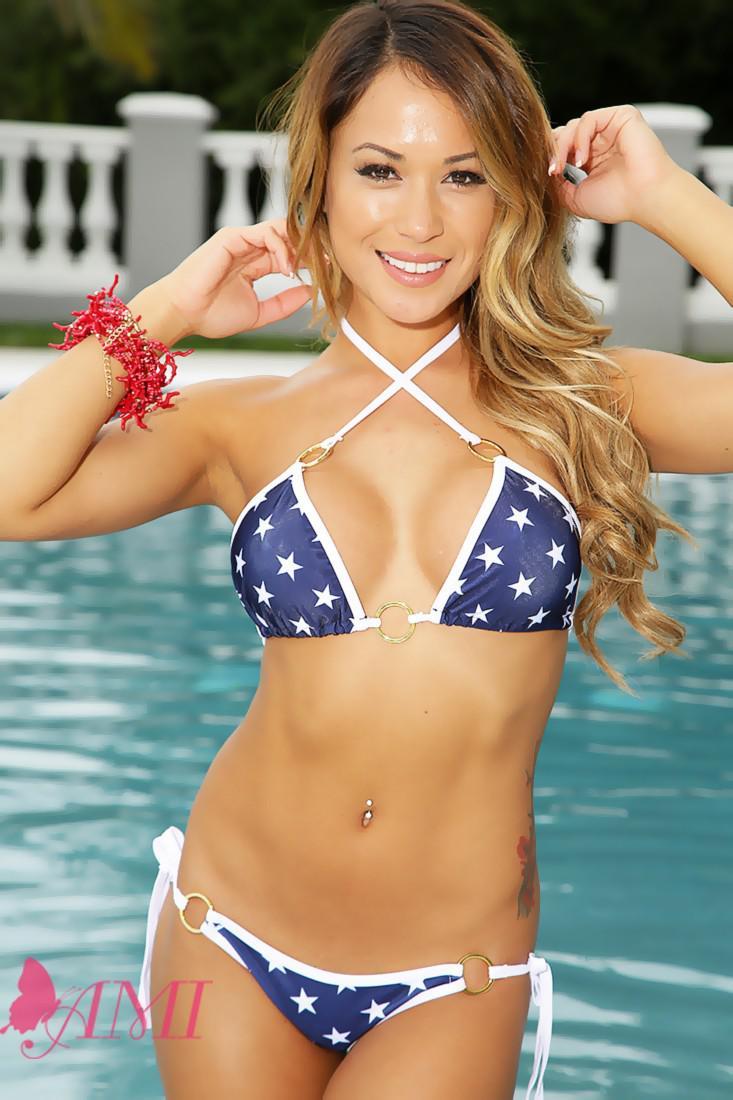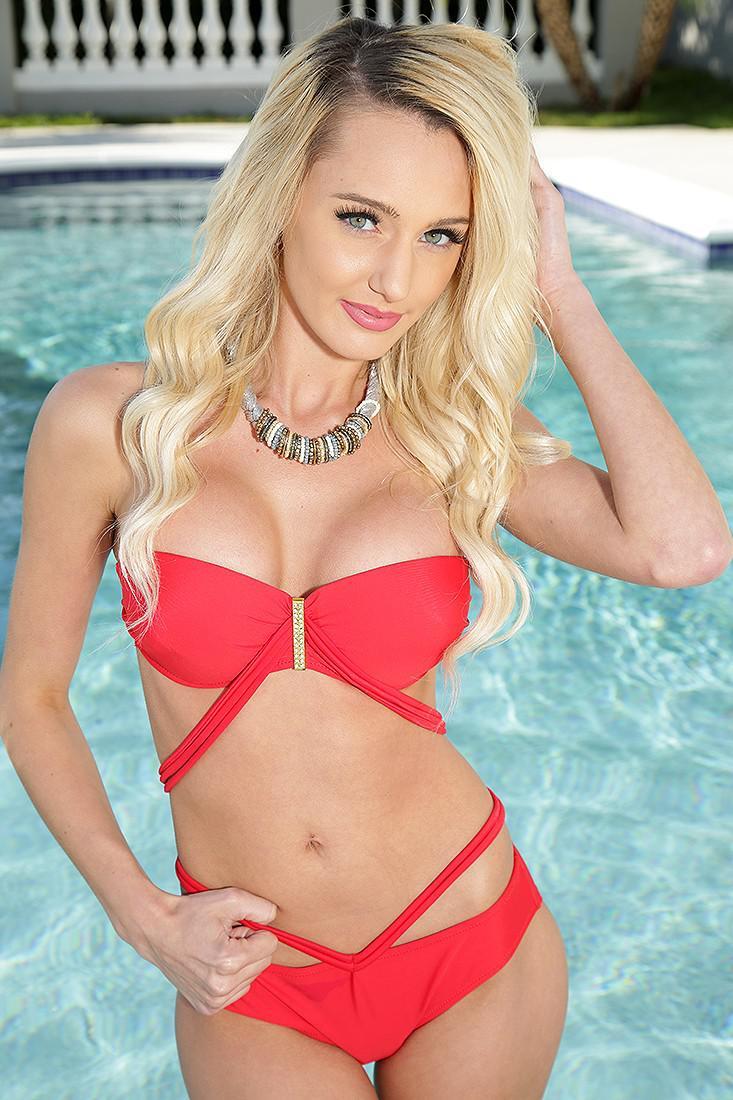The first image is the image on the left, the second image is the image on the right. Assess this claim about the two images: "In 1 of the images, 1 girl is holding her hands above her head.". Correct or not? Answer yes or no. No. The first image is the image on the left, the second image is the image on the right. Evaluate the accuracy of this statement regarding the images: "An image shows a girl in a nearly all-white bikini in front of a pool.". Is it true? Answer yes or no. No. 